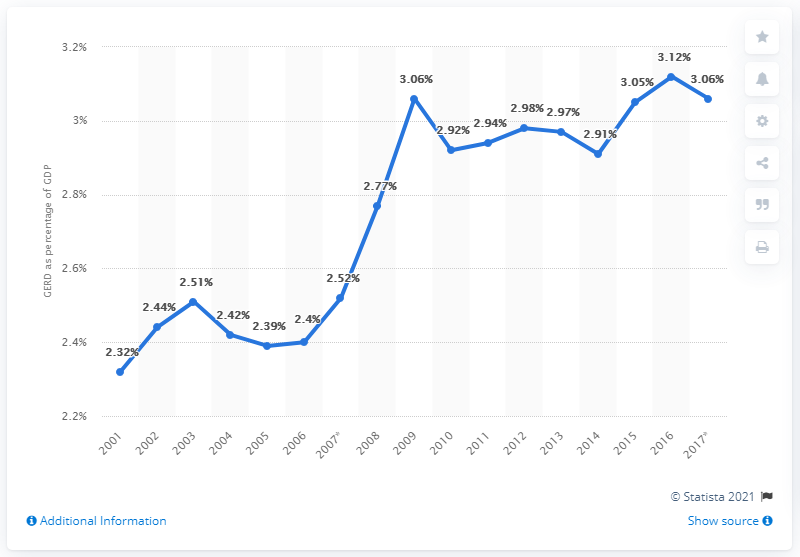List a handful of essential elements in this visual. In 2015, GERD accounted for 2.97% of Denmark's gross domestic product (GDP). In 2016, Denmark allocated 3.12% of its GDP towards research and development. 